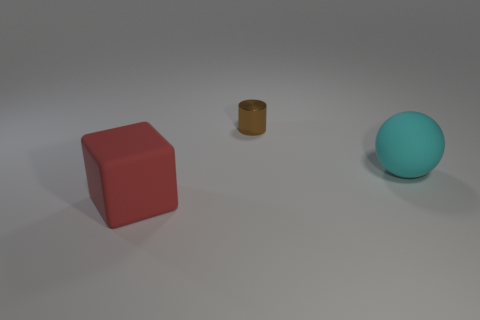Add 1 tiny green metal cylinders. How many objects exist? 4 Subtract all spheres. How many objects are left? 2 Subtract all tiny rubber things. Subtract all big red things. How many objects are left? 2 Add 3 small brown metallic cylinders. How many small brown metallic cylinders are left? 4 Add 2 purple metallic things. How many purple metallic things exist? 2 Subtract 1 cyan spheres. How many objects are left? 2 Subtract all green blocks. Subtract all blue cylinders. How many blocks are left? 1 